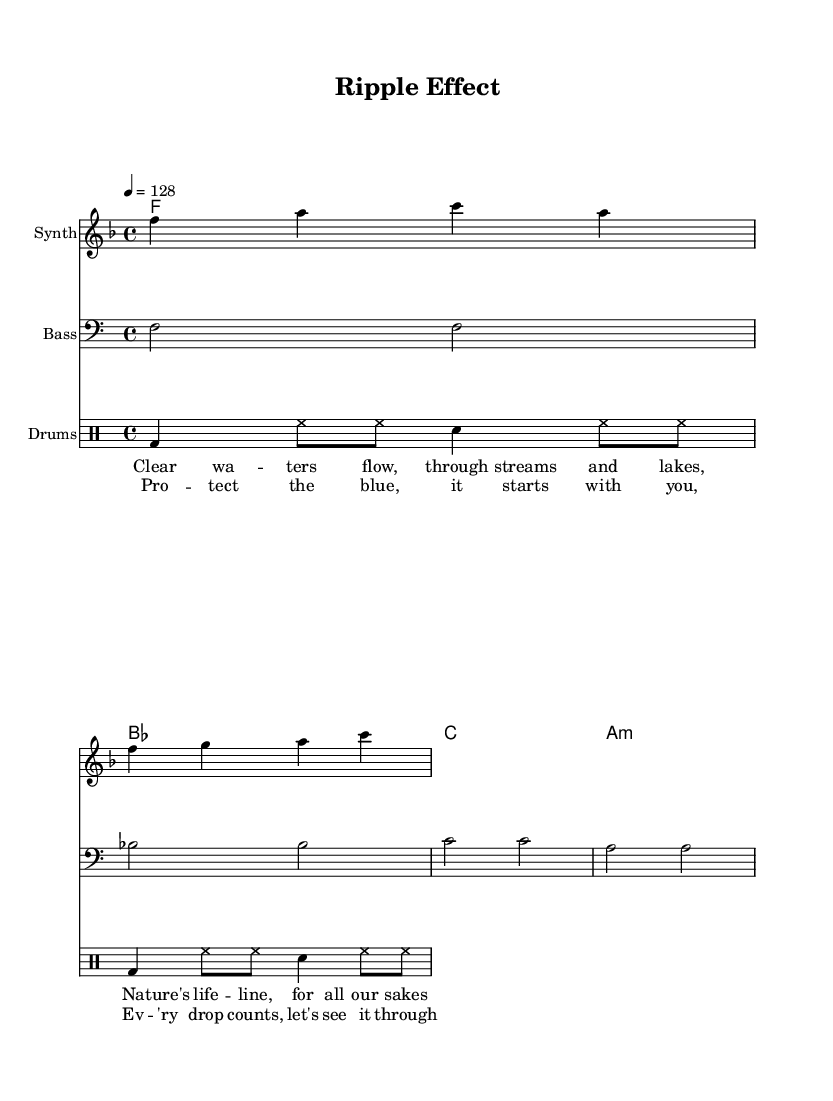What is the key signature of this music? The key signature is F major, indicated by one flat (B♭) at the beginning of the sheet music.
Answer: F major What is the time signature of this music? The time signature is 4/4, which means there are four beats in each measure, and the quarter note receives one beat. This is noted at the beginning of the sheet music just after the key signature.
Answer: 4/4 What is the tempo marking for this piece? The tempo marking is 128 beats per minute, indicated by the tempo indicator "4 = 128" at the beginning of the score.
Answer: 128 How many measures are in the melody section? The melody section has 4 measures, counting the distinct groups of notes separated by vertical lines in the score.
Answer: 4 What instrument is the melody played on? The melody is played on a Synth, as indicated by the instrument name in the staff.
Answer: Synth What is the first line of lyrics in this piece? The first line of lyrics is "Clear waters flow, through streams and lakes," which captures the piece's environmental theme. The lyrics notation starts just below the melody staff.
Answer: Clear waters flow, through streams and lakes What is the theme of the chorus? The theme of the chorus focuses on environmental conservation, as it mentions protecting the water and how "every drop counts." This is evident from the lyrics presented.
Answer: Protect the blue 